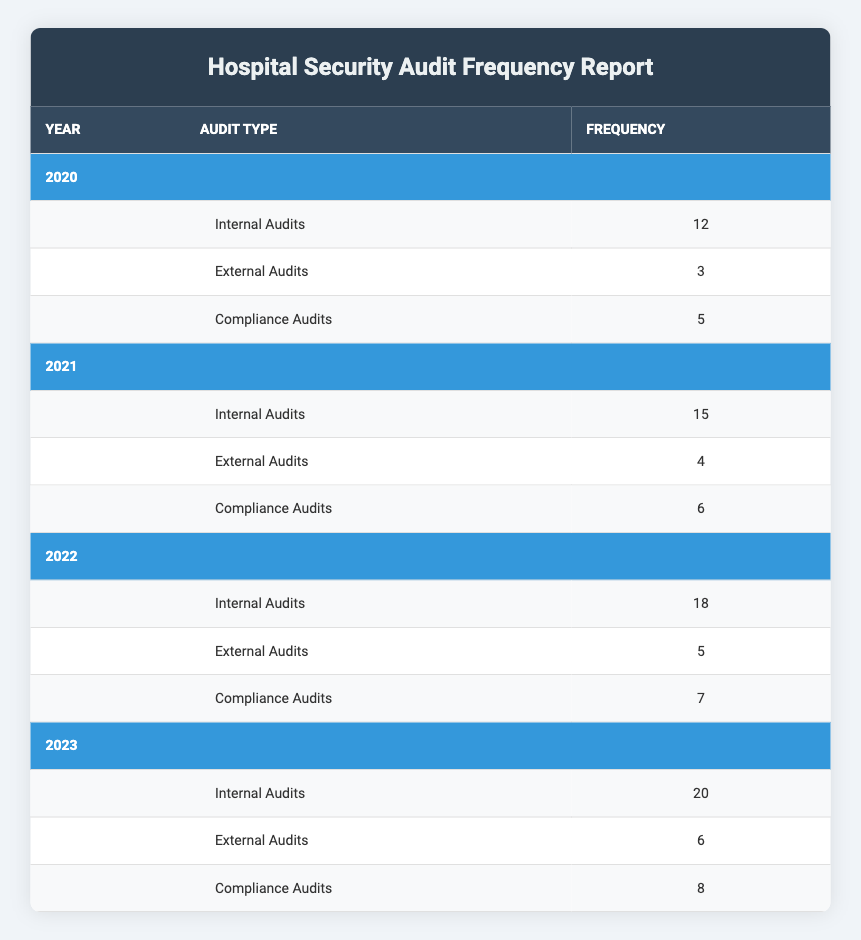What was the frequency of Internal Audits in 2021? The table shows that in the year 2021, the frequency for Internal Audits is listed as 15.
Answer: 15 What is the total number of Compliance Audits conducted from 2020 to 2023? To find the total number of Compliance Audits, we sum the values for each year: 5 (2020) + 6 (2021) + 7 (2022) + 8 (2023) = 26.
Answer: 26 Did the number of External Audits increase every year from 2020 to 2023? Checking the values for External Audits: 3 (2020), 4 (2021), 5 (2022), and 6 (2023). Each year shows a sequential increase, confirming that the number has increased every year.
Answer: Yes What was the percentage increase in Internal Audits from 2020 to 2023? First, find the increase: 20 (2023) - 12 (2020) = 8. Next, calculate the percentage increase: (8/12) * 100 = 66.67%.
Answer: 66.67% Which year had the highest frequency of External Audits? Reviewing the external audit frequencies, we see: 3 (2020), 4 (2021), 5 (2022), and 6 (2023). The highest frequency is 6 in 2023.
Answer: 2023 What was the average number of Internal Audits conducted over the four years? Summing the Internal Audits gives: 12 (2020) + 15 (2021) + 18 (2022) + 20 (2023) = 65. To find the average, divide by the number of years: 65/4 = 16.25.
Answer: 16.25 Was the number of Compliance Audits in 2020 more than the number of External Audits in 2021? The Compliance Audits in 2020 is 5, while the External Audits in 2021 is 4. Since 5 is greater than 4, the statement is true.
Answer: Yes What is the difference in frequency of Internal Audits between 2022 and 2021? The frequency in 2022 is 18 and in 2021 is 15. The difference is 18 - 15 = 3.
Answer: 3 What was the total number of audits (Internal, External, and Compliance) conducted in 2022? Summing all audits from 2022: Internal (18) + External (5) + Compliance (7) = 30.
Answer: 30 